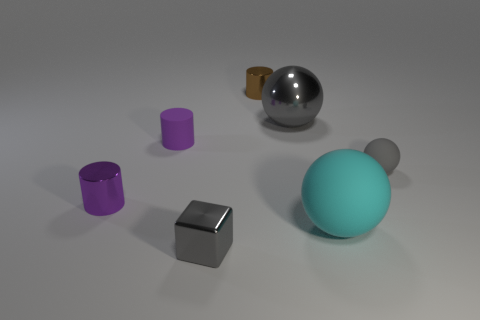If these objects were displayed in an art exhibit, what could the theme be? Displayed in an art exhibit, the theme could revolve around the interplay of forms and textures in a synthetic environment. These objects could represent a study in contrast—shiny versus matte, rigid geometry versus smooth curves—and explore the concept of industrial design as functional art. 